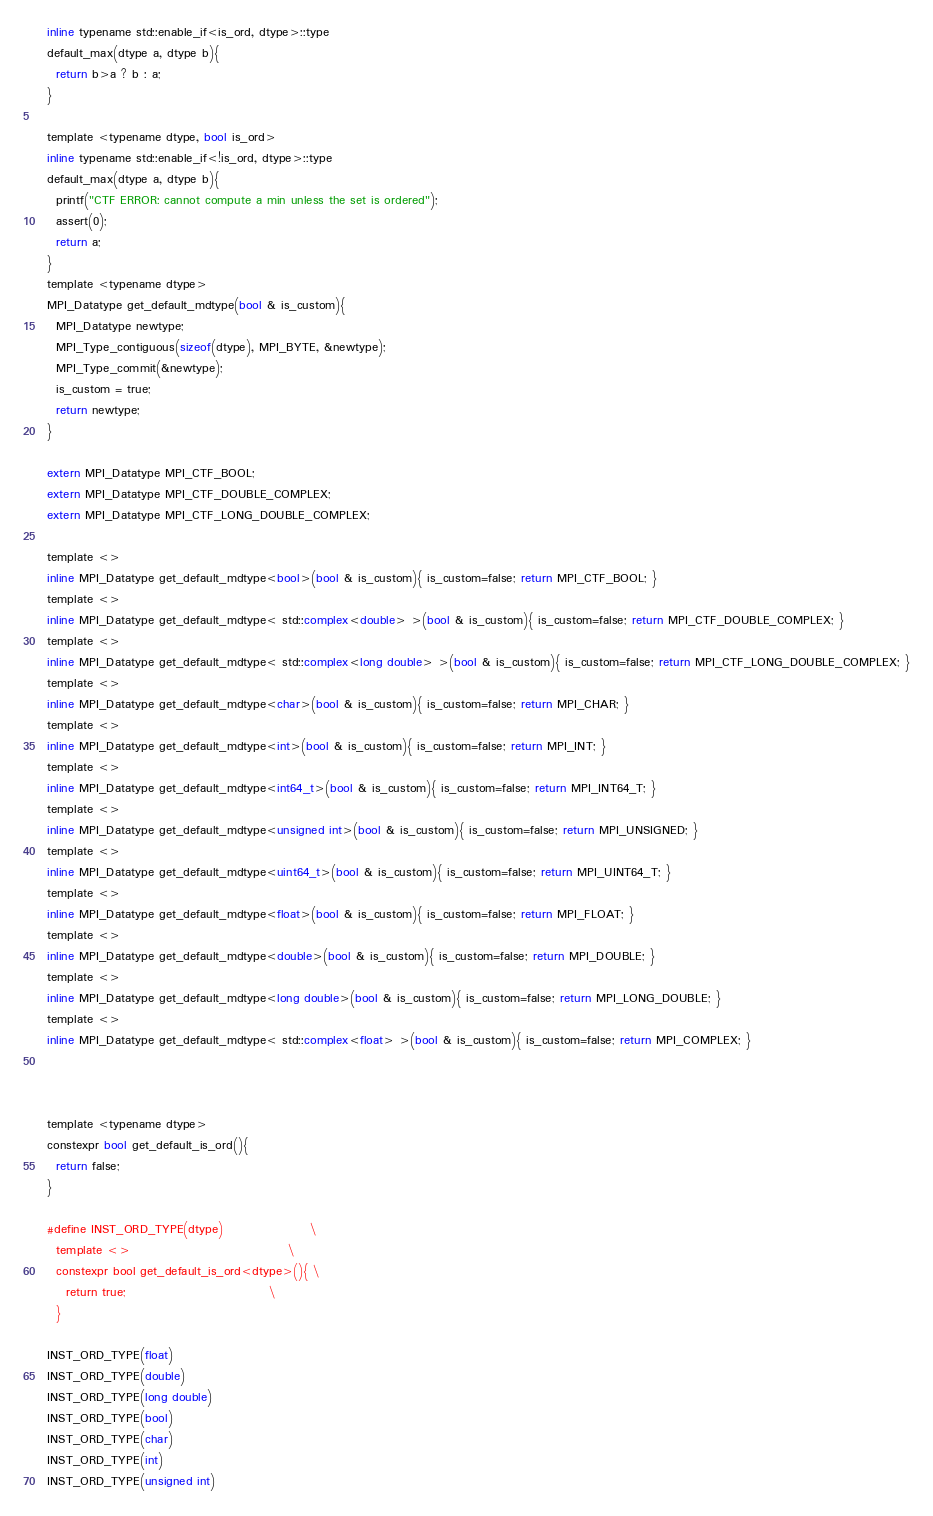<code> <loc_0><loc_0><loc_500><loc_500><_C_>  inline typename std::enable_if<is_ord, dtype>::type
  default_max(dtype a, dtype b){
    return b>a ? b : a;
  }

  template <typename dtype, bool is_ord>
  inline typename std::enable_if<!is_ord, dtype>::type
  default_max(dtype a, dtype b){
    printf("CTF ERROR: cannot compute a min unless the set is ordered");
    assert(0);
    return a;
  }
  template <typename dtype>
  MPI_Datatype get_default_mdtype(bool & is_custom){
    MPI_Datatype newtype;
    MPI_Type_contiguous(sizeof(dtype), MPI_BYTE, &newtype);
    MPI_Type_commit(&newtype);
    is_custom = true;
    return newtype;
  }

  extern MPI_Datatype MPI_CTF_BOOL;
  extern MPI_Datatype MPI_CTF_DOUBLE_COMPLEX;
  extern MPI_Datatype MPI_CTF_LONG_DOUBLE_COMPLEX;

  template <>
  inline MPI_Datatype get_default_mdtype<bool>(bool & is_custom){ is_custom=false; return MPI_CTF_BOOL; }
  template <>
  inline MPI_Datatype get_default_mdtype< std::complex<double> >(bool & is_custom){ is_custom=false; return MPI_CTF_DOUBLE_COMPLEX; }
  template <>
  inline MPI_Datatype get_default_mdtype< std::complex<long double> >(bool & is_custom){ is_custom=false; return MPI_CTF_LONG_DOUBLE_COMPLEX; }
  template <>
  inline MPI_Datatype get_default_mdtype<char>(bool & is_custom){ is_custom=false; return MPI_CHAR; }
  template <>
  inline MPI_Datatype get_default_mdtype<int>(bool & is_custom){ is_custom=false; return MPI_INT; }
  template <>
  inline MPI_Datatype get_default_mdtype<int64_t>(bool & is_custom){ is_custom=false; return MPI_INT64_T; }
  template <>
  inline MPI_Datatype get_default_mdtype<unsigned int>(bool & is_custom){ is_custom=false; return MPI_UNSIGNED; }
  template <>
  inline MPI_Datatype get_default_mdtype<uint64_t>(bool & is_custom){ is_custom=false; return MPI_UINT64_T; }
  template <>
  inline MPI_Datatype get_default_mdtype<float>(bool & is_custom){ is_custom=false; return MPI_FLOAT; }
  template <>
  inline MPI_Datatype get_default_mdtype<double>(bool & is_custom){ is_custom=false; return MPI_DOUBLE; }
  template <>
  inline MPI_Datatype get_default_mdtype<long double>(bool & is_custom){ is_custom=false; return MPI_LONG_DOUBLE; }
  template <>
  inline MPI_Datatype get_default_mdtype< std::complex<float> >(bool & is_custom){ is_custom=false; return MPI_COMPLEX; }



  template <typename dtype>
  constexpr bool get_default_is_ord(){
    return false;
  }

  #define INST_ORD_TYPE(dtype)                  \
    template <>                                 \
    constexpr bool get_default_is_ord<dtype>(){ \
      return true;                              \
    }

  INST_ORD_TYPE(float)
  INST_ORD_TYPE(double)
  INST_ORD_TYPE(long double)
  INST_ORD_TYPE(bool)
  INST_ORD_TYPE(char)
  INST_ORD_TYPE(int)
  INST_ORD_TYPE(unsigned int)</code> 